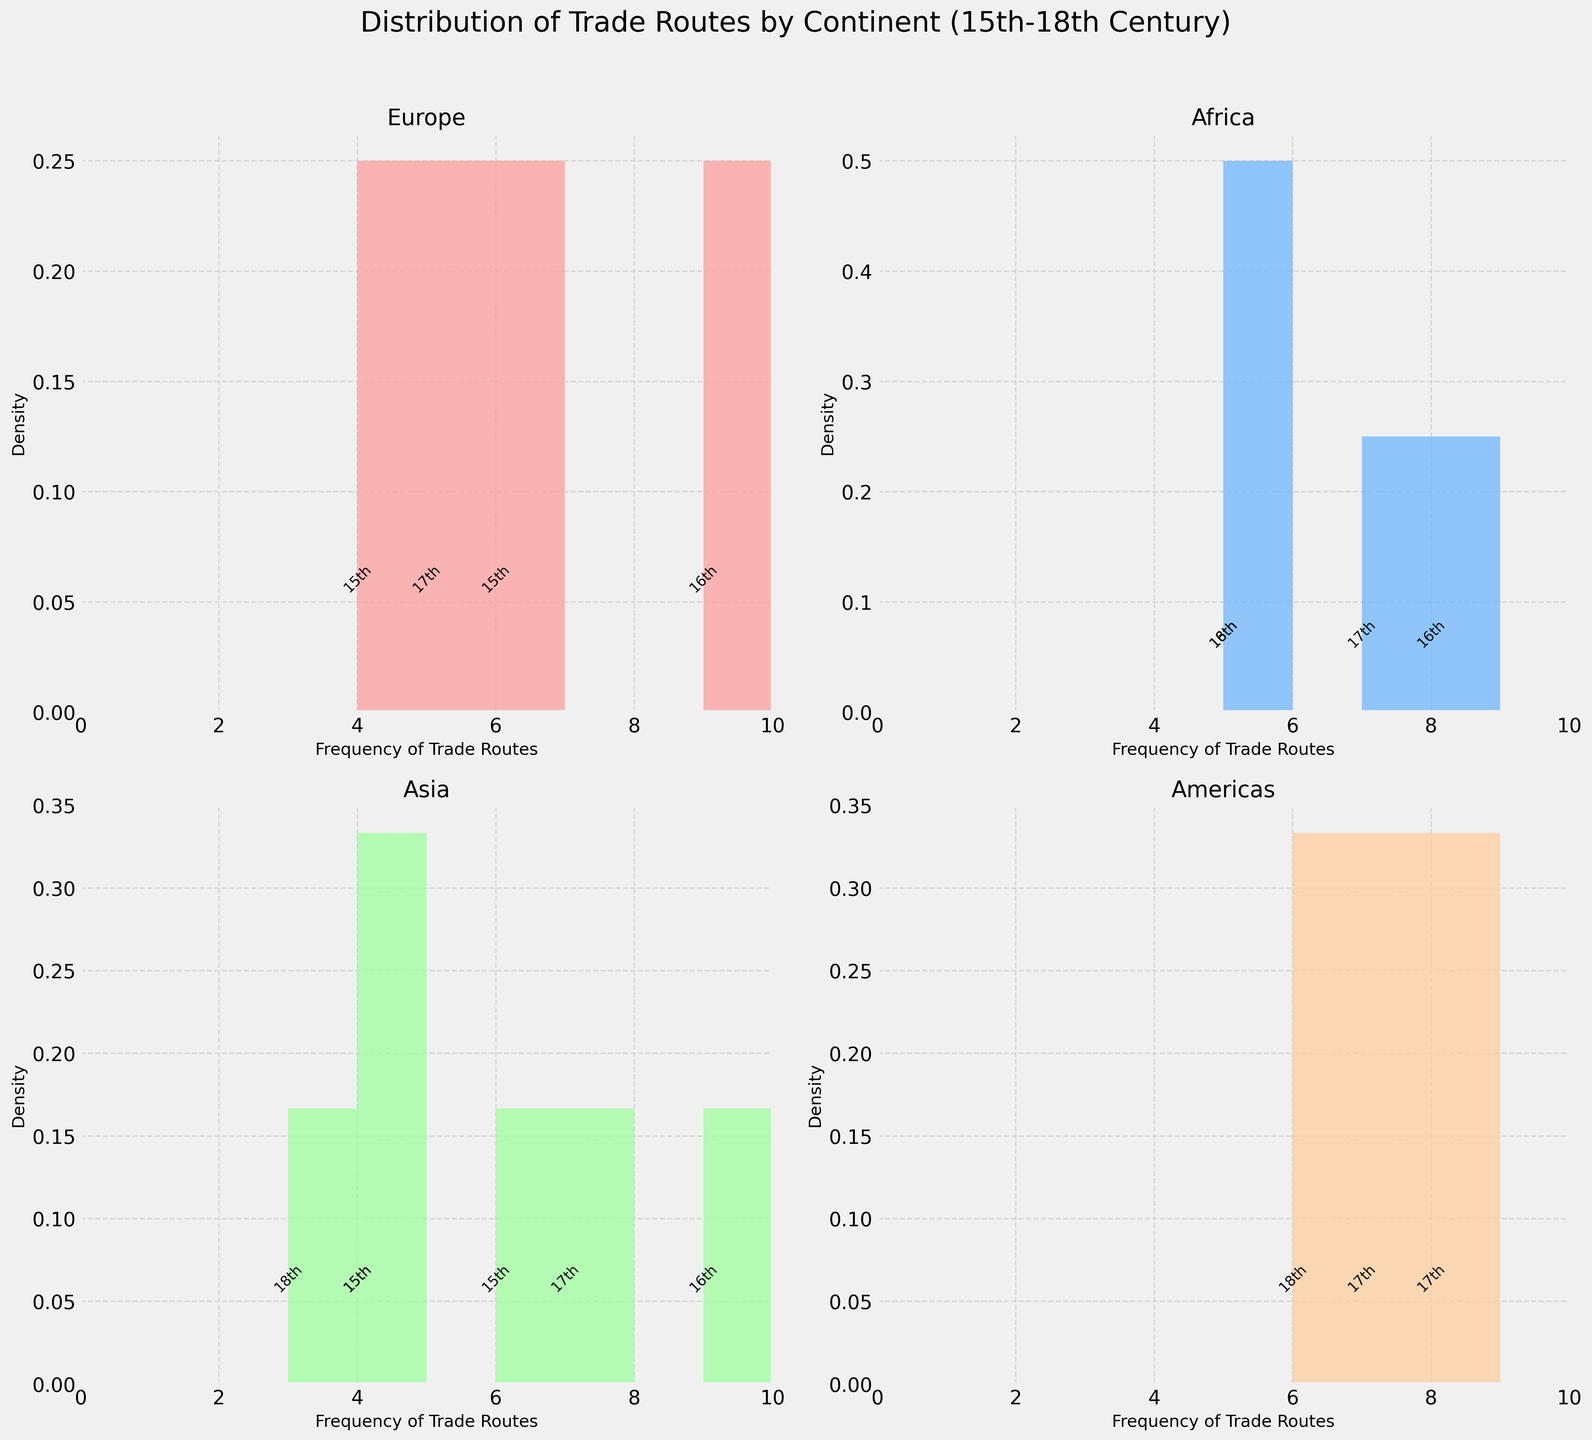Which continent has the highest peak in the density plot? By examining the peaks of the density curves, the continent with the highest peak can be identified. A peak indicates the frequency at which certain trade routes were most common.
Answer: Europe In which continent is the density of trade route frequencies relatively uniform across the 15th to 18th centuries? To find uniform distribution, we must look for a histogram without a distinct peak, displaying a more even spread across the frequency values.
Answer: Americas Which continent has the trade route with the highest frequency and what is that frequency? By identifying the histogram that extends the farthest along the "Frequency of Trade Routes" axis, we can determine the continent with the most frequent trade route.
Answer: Asia, 9 Which two continents have annotations for the 17th century? By looking for annotations labeled "17th" on the x-axis, we can determine which two continents have trade routes from the 17th century.
Answer: Europe, Americas Compare the spread of trade route frequencies between Europe and Asia. Which one is more spread out? We compare the ranges covered by the histograms. The spread can be judged by how wide the rectangle of the histogram is along the x-axis.
Answer: Europe What is the most common frequency range for African trade routes? Identifying the region with the highest density in Africa’s subplot provides us with the frequency range that appears most often.
Answer: 5-8 Are there any continents whose maximum trade route frequency is less than the maximum frequency observed in Europe? Comparing the maximum frequencies across all continent plots and checking if they are lower than Europe’s highest frequency helps us find the answer.
Answer: Yes (Africa and Americas) Which continent's density plot has trade routes primarily distributed around two distinct frequencies? By identifying density plots with two notable peaks or clusters, we can determine the continent with this bimodal distribution.
Answer: Africa Which continents show significant trade route activity in the 15th century? We need to look for annotations labeled "15th" to determine which continents had notable trade routes during this time.
Answer: Europe, Asia What frequency ranges are most common for trade routes in the Americas during the 18th century? By looking at the annotations for the 18th century within the Americas plot, we can identify the frequency ranges around these annotations.
Answer: 5-7 